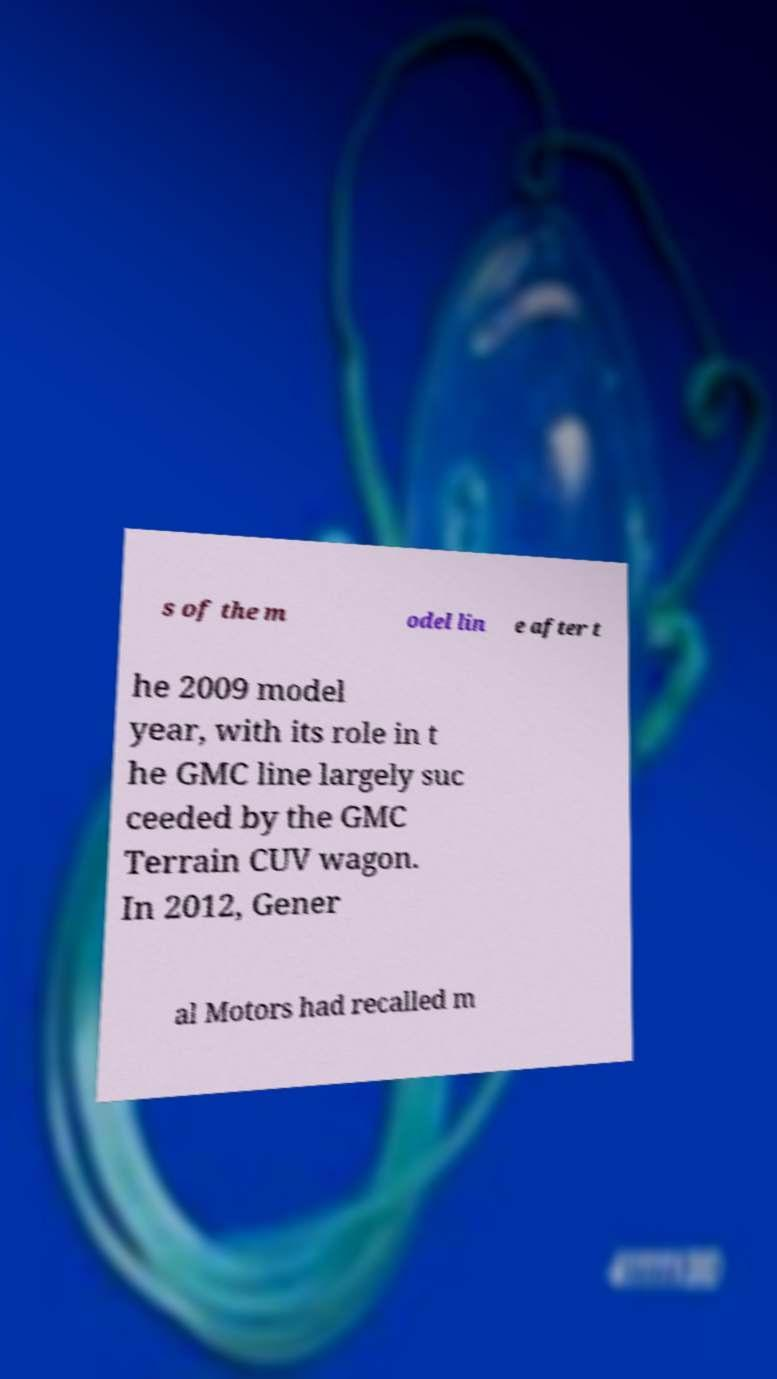I need the written content from this picture converted into text. Can you do that? s of the m odel lin e after t he 2009 model year, with its role in t he GMC line largely suc ceeded by the GMC Terrain CUV wagon. In 2012, Gener al Motors had recalled m 